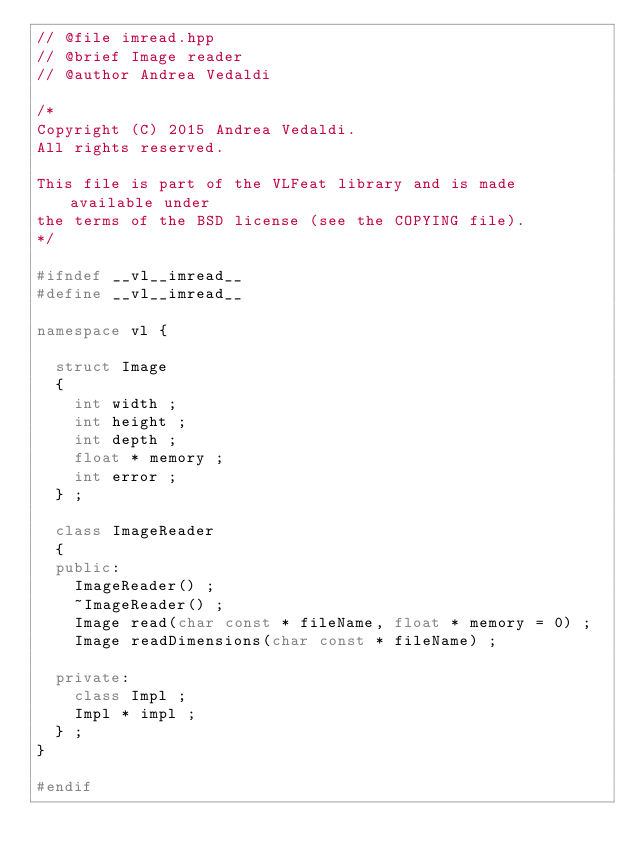<code> <loc_0><loc_0><loc_500><loc_500><_C++_>// @file imread.hpp
// @brief Image reader
// @author Andrea Vedaldi

/*
Copyright (C) 2015 Andrea Vedaldi.
All rights reserved.

This file is part of the VLFeat library and is made available under
the terms of the BSD license (see the COPYING file).
*/

#ifndef __vl__imread__
#define __vl__imread__

namespace vl {

  struct Image
  {
    int width ;
    int height ;
    int depth ;
    float * memory ;
    int error ;
  } ;

  class ImageReader
  {
  public:
    ImageReader() ;
    ~ImageReader() ;
    Image read(char const * fileName, float * memory = 0) ;
    Image readDimensions(char const * fileName) ;

  private:
    class Impl ;
    Impl * impl ;
  } ;
}

#endif
</code> 